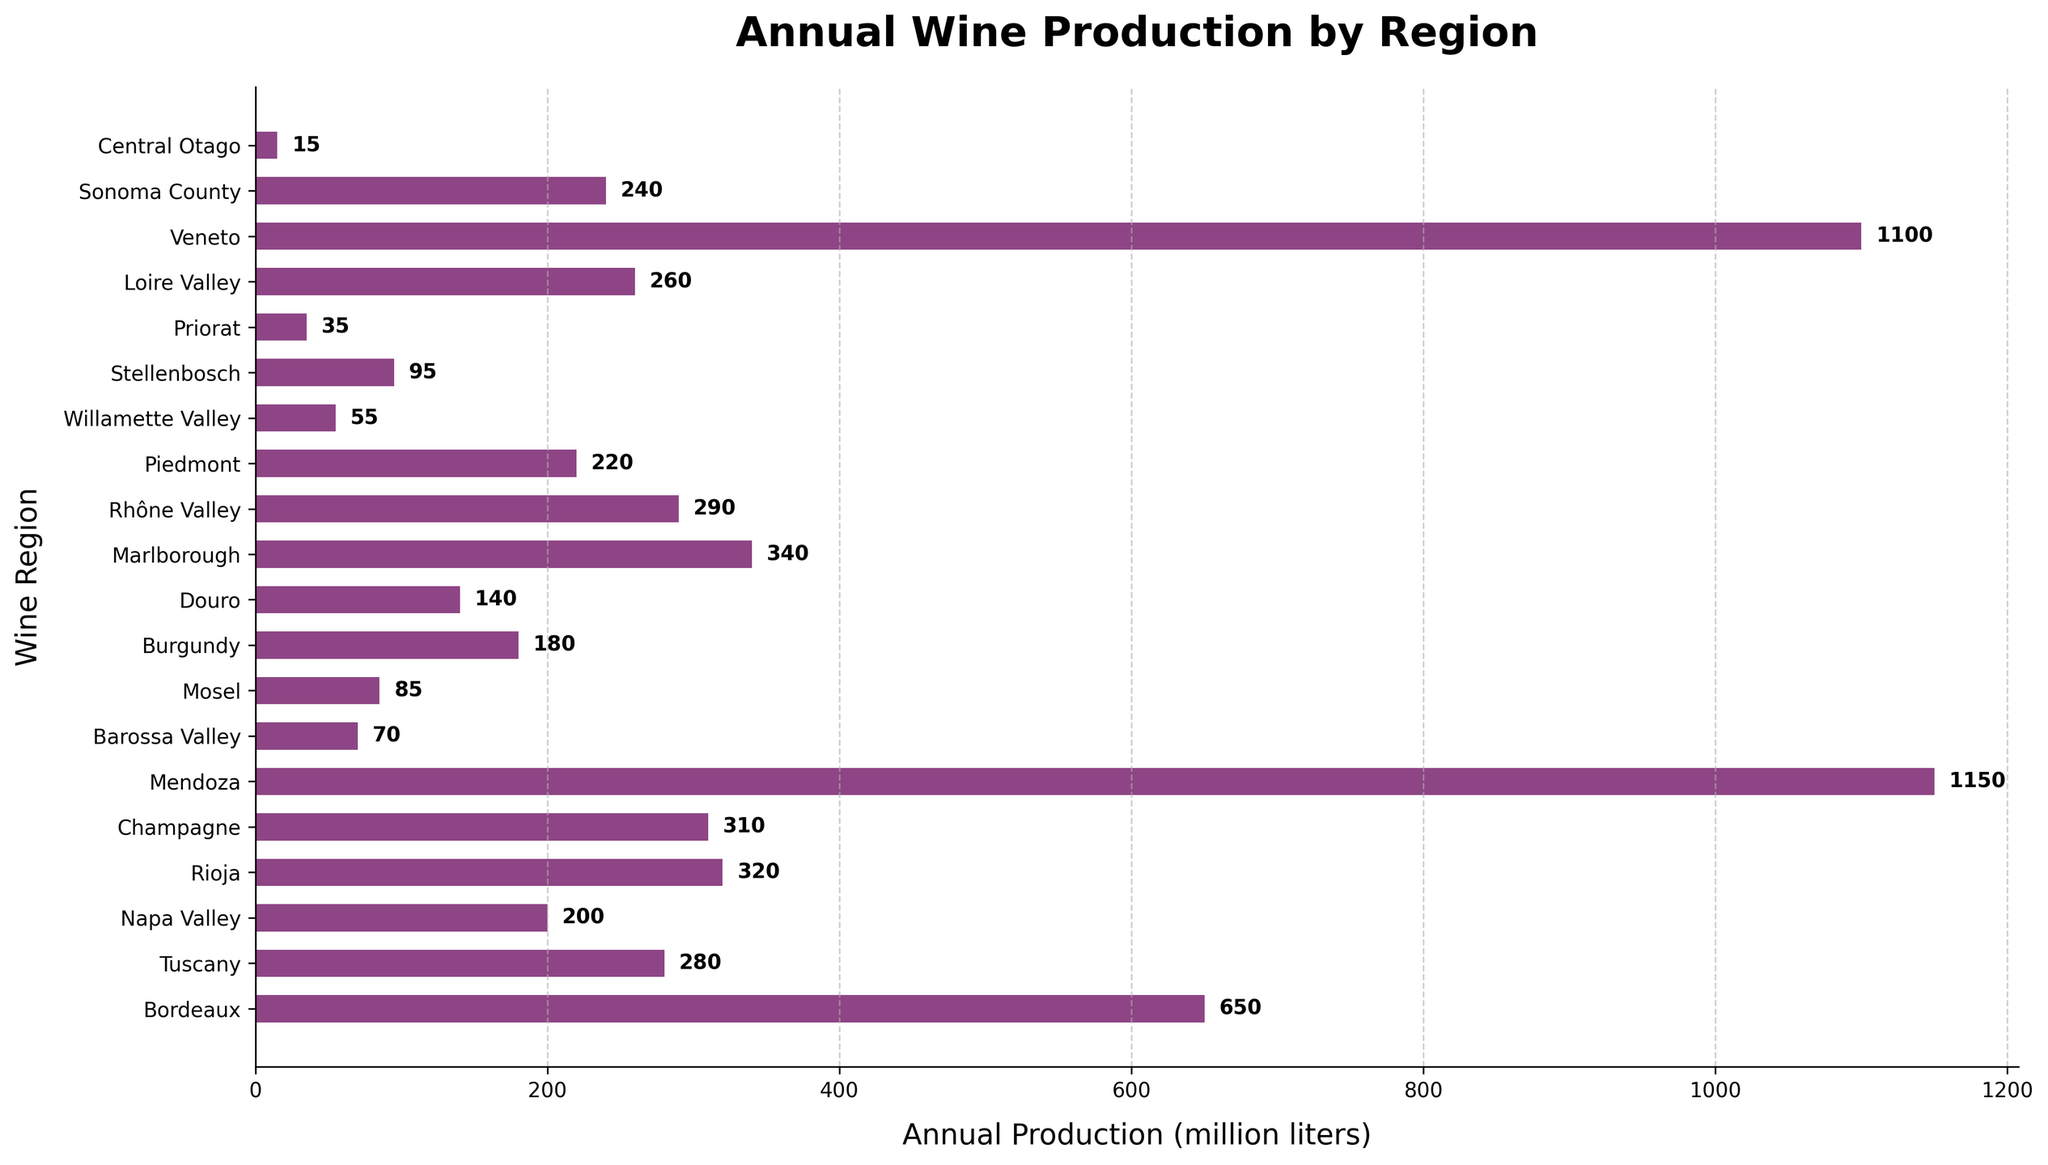Which region has the highest wine production? The tallest bar represents the region with the highest production. In this chart, the region associated with the bar corresponding to 1150 million liters is Mendoza.
Answer: Mendoza Which region has the lowest wine production? The shortest bar will represent the region with the lowest production. In this chart, the region associated with the bar corresponding to 15 million liters is Central Otago.
Answer: Central Otago How much higher is Mendoza's wine production compared to Barossa Valley's? Identify the production values for Mendoza (1150 million liters) and Barossa Valley (70 million liters). Subtract the smaller value from the larger one: 1150 - 70.
Answer: 1080 million liters What is the difference in production between Bordeaux and Napa Valley? Identify the production values for Bordeaux (650 million liters) and Napa Valley (200 million liters). Subtract the smaller value from the larger one: 650 - 200.
Answer: 450 million liters Which regions have production volumes that fall between 100 and 300 million liters? Look at the bars whose production volumes are within the specified range. The regions are Champagne (310), Douro (140), Burgundy (180), Moscow (85), Stellenbosch (95), Veneto (110), Napa Valley (200).
Answer: Douro, Burgundy, Rhône Valley, Loire Valley, Sonoma County, Piedmont, Tuscany Which region produces more wine: Rioja or Champagne? Compare the bars for Rioja (320 million liters) and Champagne (310 million liters). The longer bar indicates Rioja.
Answer: Rioja What is the combined wine production of Tuscany, Napa Valley, and Rioja? Identify the production values for Tuscany (280 million liters), Napa Valley (200 million liters), and Rioja (320 million liters). Sum them up: 280 + 200 + 320.
Answer: 800 million liters What is the average production of the bottom three wine-producing regions? Identify the production values for the bottom three regions: Central Otago (15 million liters), Priorat (35 million liters), and Willamette Valley (55 million liters). Calculate the average: (15 + 35 + 55) / 3.
Answer: 35 million liters How does the production of Marlborough compare to Rhône Valley? Identify the production values for Marlborough (340 million liters) and Rhône Valley (290 million liters). Marlborough's production is higher as indicated by the longer bar.
Answer: Marlborough Which region has a production volume closest to 200 million liters? Identify the regions with production volumes around 200 million liters. Napa Valley has exactly 200 million liters, making it the closest match.
Answer: Napa Valley 